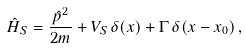Convert formula to latex. <formula><loc_0><loc_0><loc_500><loc_500>\hat { H } _ { S } = \frac { \hat { p } ^ { 2 } } { 2 m } + V _ { S } \, \delta ( x ) + \Gamma \, \delta ( x - x _ { 0 } ) \, ,</formula> 